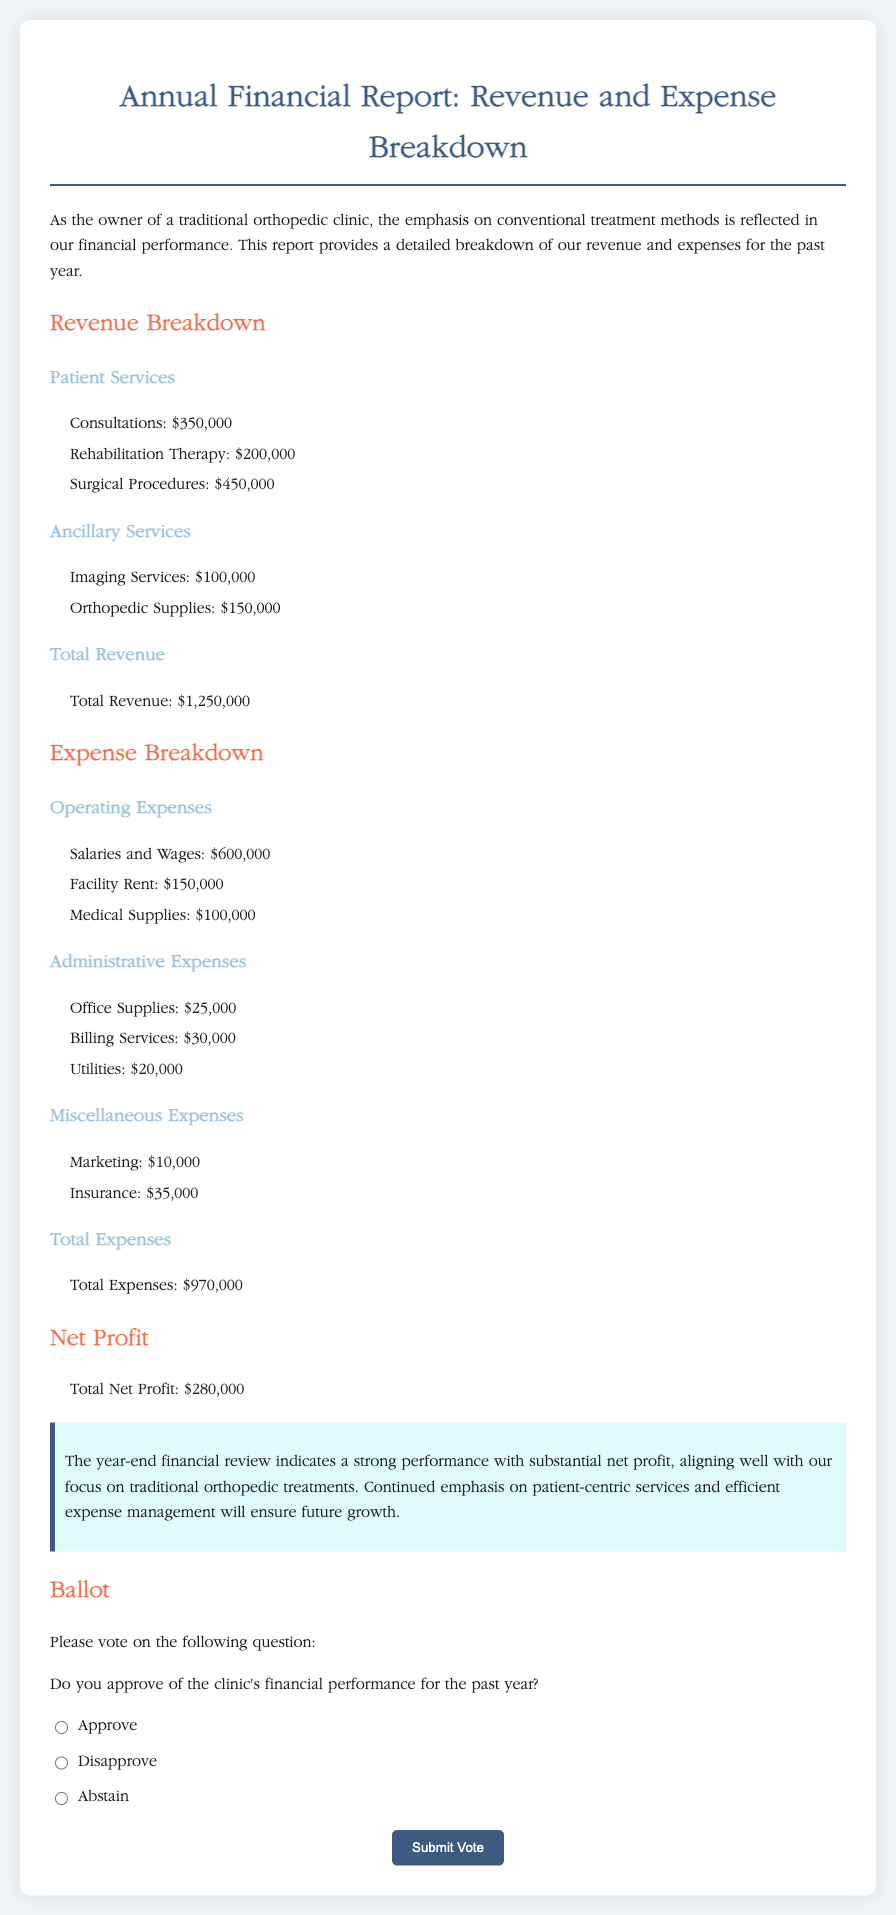What is the total revenue? The total revenue is provided in the document under the revenue section, which sums up all patient services and ancillary services.
Answer: $1,250,000 What is the net profit? The net profit is calculated as total revenue minus total expenses, which is presented in the net profit section.
Answer: $280,000 What were the salaries and wages expenses? Salaries and wages are listed as part of the operating expenses in the document.
Answer: $600,000 How much was spent on marketing? Marketing costs are included under miscellaneous expenses in the expense breakdown section.
Answer: $10,000 What is the total of administrative expenses? Administrative expenses consist of several line items, the total amount can be inferred by their summation.
Answer: $75,000 Do you approve of the clinic's financial performance? This question is part of the ballot, asking for approval of the overall financial performance for the year.
Answer: (Answer is subjective, depends on voter response.) What is the facility rent expense? The facility rent is listed among the operating expenses section of the document.
Answer: $150,000 What type of clinic is this report for? The introduction specifies the nature of the clinic the report pertains to.
Answer: Orthopedic clinic 